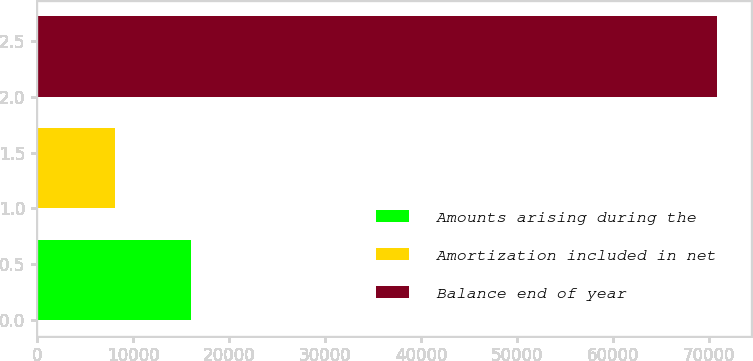<chart> <loc_0><loc_0><loc_500><loc_500><bar_chart><fcel>Amounts arising during the<fcel>Amortization included in net<fcel>Balance end of year<nl><fcel>16031<fcel>8159<fcel>70803<nl></chart> 